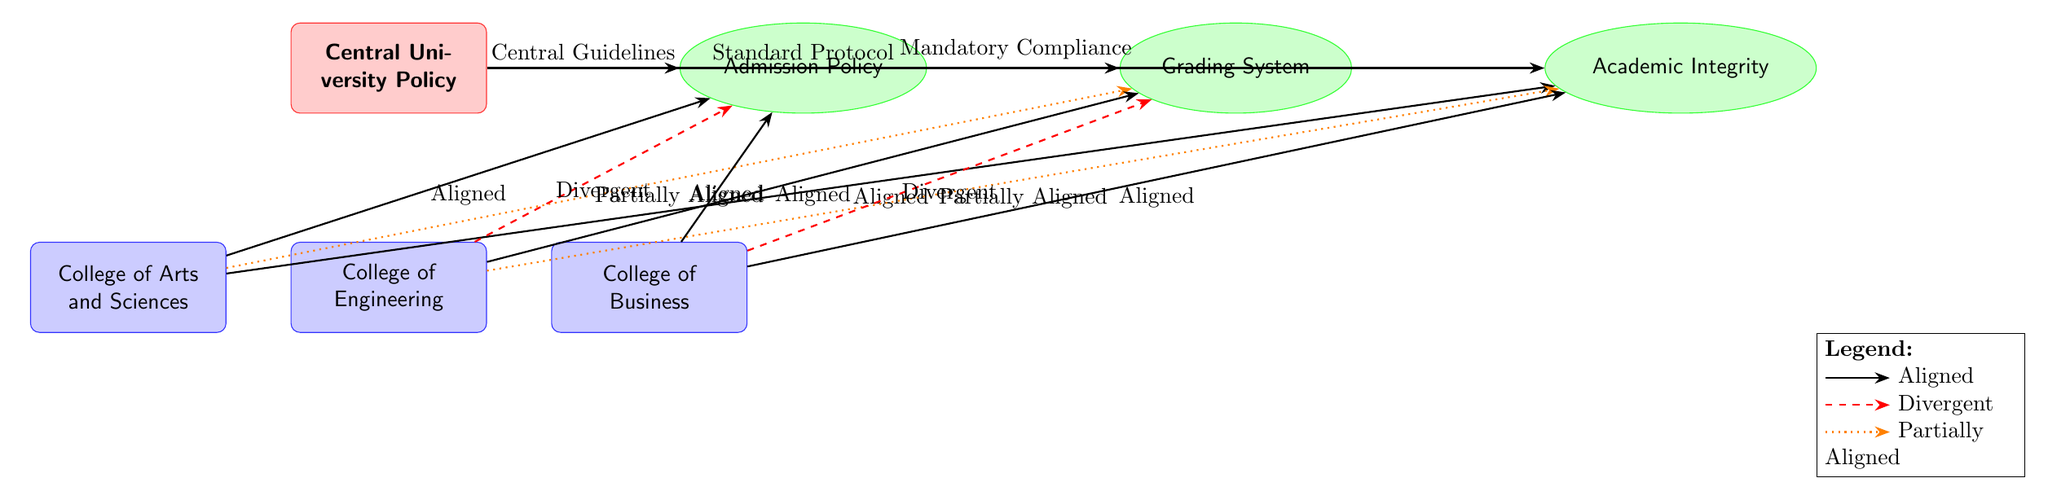What are the names of the three colleges depicted in the diagram? The diagram shows three colleges: the College of Arts and Sciences, the College of Engineering, and the College of Business. This information is identified by the labeled nodes labeled as colleges located below the central policy node.
Answer: College of Arts and Sciences, College of Engineering, College of Business How many policies are shown in the diagram? The diagram includes three policies: Admission Policy, Grading System, and Academic Integrity. These policies are represented as nodes to the right of the central university policy.
Answer: 3 Which college has a divergent connection for the Admission Policy? The College of Engineering has a divergent connection for the Admission Policy, as indicated by the dashed red arrow connecting it to the respective policy node. This represents a difference from the university's central guidelines.
Answer: College of Engineering Which college is partially aligned with the Grading System? The College of Arts and Sciences and the College of Engineering are both partially aligned with the Grading System, as shown by the dotted orange line linking each college to the Grading System node. This means they do not fully conform to the standard protocols outlined in the central policy.
Answer: College of Arts and Sciences, College of Engineering What type of connection does the College of Business have with the Grading System? The College of Business has a divergent connection with the Grading System, indicated by the dashed red line. This shows that the college's grading system diverges from the central university policy, indicating a significant difference.
Answer: Divergent Which policy is consistently marked as aligned across all colleges? The Academic Integrity policy is aligned across all colleges, as evidenced by solid black lines from each college to this policy node, indicating that all colleges follow the mandatory compliance as per the central policy.
Answer: Academic Integrity 